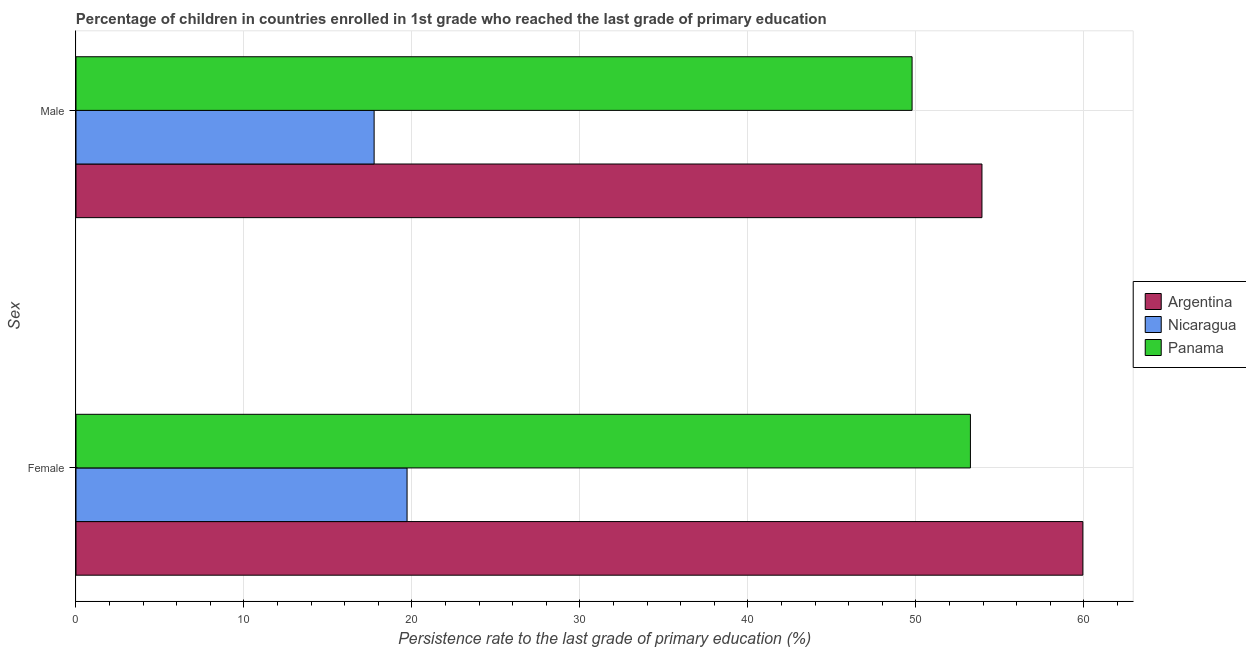How many groups of bars are there?
Your answer should be compact. 2. Are the number of bars per tick equal to the number of legend labels?
Offer a terse response. Yes. Are the number of bars on each tick of the Y-axis equal?
Keep it short and to the point. Yes. How many bars are there on the 2nd tick from the top?
Your response must be concise. 3. What is the persistence rate of female students in Nicaragua?
Ensure brevity in your answer.  19.71. Across all countries, what is the maximum persistence rate of male students?
Ensure brevity in your answer.  53.93. Across all countries, what is the minimum persistence rate of male students?
Offer a terse response. 17.75. In which country was the persistence rate of female students minimum?
Keep it short and to the point. Nicaragua. What is the total persistence rate of female students in the graph?
Provide a succinct answer. 132.89. What is the difference between the persistence rate of female students in Panama and that in Nicaragua?
Your answer should be very brief. 33.54. What is the difference between the persistence rate of male students in Nicaragua and the persistence rate of female students in Panama?
Your answer should be very brief. -35.5. What is the average persistence rate of female students per country?
Offer a terse response. 44.3. What is the difference between the persistence rate of female students and persistence rate of male students in Nicaragua?
Ensure brevity in your answer.  1.96. In how many countries, is the persistence rate of female students greater than 54 %?
Offer a terse response. 1. What is the ratio of the persistence rate of female students in Nicaragua to that in Argentina?
Offer a terse response. 0.33. Is the persistence rate of male students in Nicaragua less than that in Argentina?
Give a very brief answer. Yes. What does the 1st bar from the top in Female represents?
Ensure brevity in your answer.  Panama. What does the 3rd bar from the bottom in Female represents?
Keep it short and to the point. Panama. How many bars are there?
Provide a short and direct response. 6. Are all the bars in the graph horizontal?
Ensure brevity in your answer.  Yes. Are the values on the major ticks of X-axis written in scientific E-notation?
Make the answer very short. No. Does the graph contain any zero values?
Provide a succinct answer. No. Does the graph contain grids?
Provide a short and direct response. Yes. Where does the legend appear in the graph?
Provide a succinct answer. Center right. How many legend labels are there?
Give a very brief answer. 3. How are the legend labels stacked?
Keep it short and to the point. Vertical. What is the title of the graph?
Offer a very short reply. Percentage of children in countries enrolled in 1st grade who reached the last grade of primary education. Does "Iraq" appear as one of the legend labels in the graph?
Your answer should be very brief. No. What is the label or title of the X-axis?
Keep it short and to the point. Persistence rate to the last grade of primary education (%). What is the label or title of the Y-axis?
Your response must be concise. Sex. What is the Persistence rate to the last grade of primary education (%) in Argentina in Female?
Your response must be concise. 59.94. What is the Persistence rate to the last grade of primary education (%) in Nicaragua in Female?
Keep it short and to the point. 19.71. What is the Persistence rate to the last grade of primary education (%) of Panama in Female?
Ensure brevity in your answer.  53.25. What is the Persistence rate to the last grade of primary education (%) in Argentina in Male?
Ensure brevity in your answer.  53.93. What is the Persistence rate to the last grade of primary education (%) of Nicaragua in Male?
Offer a very short reply. 17.75. What is the Persistence rate to the last grade of primary education (%) in Panama in Male?
Your response must be concise. 49.77. Across all Sex, what is the maximum Persistence rate to the last grade of primary education (%) in Argentina?
Ensure brevity in your answer.  59.94. Across all Sex, what is the maximum Persistence rate to the last grade of primary education (%) of Nicaragua?
Keep it short and to the point. 19.71. Across all Sex, what is the maximum Persistence rate to the last grade of primary education (%) of Panama?
Your response must be concise. 53.25. Across all Sex, what is the minimum Persistence rate to the last grade of primary education (%) in Argentina?
Your response must be concise. 53.93. Across all Sex, what is the minimum Persistence rate to the last grade of primary education (%) in Nicaragua?
Give a very brief answer. 17.75. Across all Sex, what is the minimum Persistence rate to the last grade of primary education (%) in Panama?
Offer a very short reply. 49.77. What is the total Persistence rate to the last grade of primary education (%) in Argentina in the graph?
Your answer should be compact. 113.87. What is the total Persistence rate to the last grade of primary education (%) in Nicaragua in the graph?
Offer a very short reply. 37.46. What is the total Persistence rate to the last grade of primary education (%) in Panama in the graph?
Offer a very short reply. 103.02. What is the difference between the Persistence rate to the last grade of primary education (%) of Argentina in Female and that in Male?
Give a very brief answer. 6.01. What is the difference between the Persistence rate to the last grade of primary education (%) in Nicaragua in Female and that in Male?
Your answer should be very brief. 1.96. What is the difference between the Persistence rate to the last grade of primary education (%) of Panama in Female and that in Male?
Ensure brevity in your answer.  3.47. What is the difference between the Persistence rate to the last grade of primary education (%) of Argentina in Female and the Persistence rate to the last grade of primary education (%) of Nicaragua in Male?
Provide a short and direct response. 42.19. What is the difference between the Persistence rate to the last grade of primary education (%) of Argentina in Female and the Persistence rate to the last grade of primary education (%) of Panama in Male?
Give a very brief answer. 10.17. What is the difference between the Persistence rate to the last grade of primary education (%) in Nicaragua in Female and the Persistence rate to the last grade of primary education (%) in Panama in Male?
Give a very brief answer. -30.06. What is the average Persistence rate to the last grade of primary education (%) in Argentina per Sex?
Make the answer very short. 56.94. What is the average Persistence rate to the last grade of primary education (%) in Nicaragua per Sex?
Your answer should be compact. 18.73. What is the average Persistence rate to the last grade of primary education (%) of Panama per Sex?
Your answer should be compact. 51.51. What is the difference between the Persistence rate to the last grade of primary education (%) in Argentina and Persistence rate to the last grade of primary education (%) in Nicaragua in Female?
Your answer should be compact. 40.23. What is the difference between the Persistence rate to the last grade of primary education (%) in Argentina and Persistence rate to the last grade of primary education (%) in Panama in Female?
Offer a very short reply. 6.69. What is the difference between the Persistence rate to the last grade of primary education (%) of Nicaragua and Persistence rate to the last grade of primary education (%) of Panama in Female?
Keep it short and to the point. -33.54. What is the difference between the Persistence rate to the last grade of primary education (%) of Argentina and Persistence rate to the last grade of primary education (%) of Nicaragua in Male?
Your answer should be compact. 36.18. What is the difference between the Persistence rate to the last grade of primary education (%) of Argentina and Persistence rate to the last grade of primary education (%) of Panama in Male?
Give a very brief answer. 4.16. What is the difference between the Persistence rate to the last grade of primary education (%) in Nicaragua and Persistence rate to the last grade of primary education (%) in Panama in Male?
Offer a terse response. -32.02. What is the ratio of the Persistence rate to the last grade of primary education (%) in Argentina in Female to that in Male?
Offer a very short reply. 1.11. What is the ratio of the Persistence rate to the last grade of primary education (%) of Nicaragua in Female to that in Male?
Give a very brief answer. 1.11. What is the ratio of the Persistence rate to the last grade of primary education (%) of Panama in Female to that in Male?
Your response must be concise. 1.07. What is the difference between the highest and the second highest Persistence rate to the last grade of primary education (%) in Argentina?
Your answer should be very brief. 6.01. What is the difference between the highest and the second highest Persistence rate to the last grade of primary education (%) in Nicaragua?
Give a very brief answer. 1.96. What is the difference between the highest and the second highest Persistence rate to the last grade of primary education (%) in Panama?
Make the answer very short. 3.47. What is the difference between the highest and the lowest Persistence rate to the last grade of primary education (%) of Argentina?
Your answer should be very brief. 6.01. What is the difference between the highest and the lowest Persistence rate to the last grade of primary education (%) of Nicaragua?
Offer a very short reply. 1.96. What is the difference between the highest and the lowest Persistence rate to the last grade of primary education (%) in Panama?
Offer a very short reply. 3.47. 